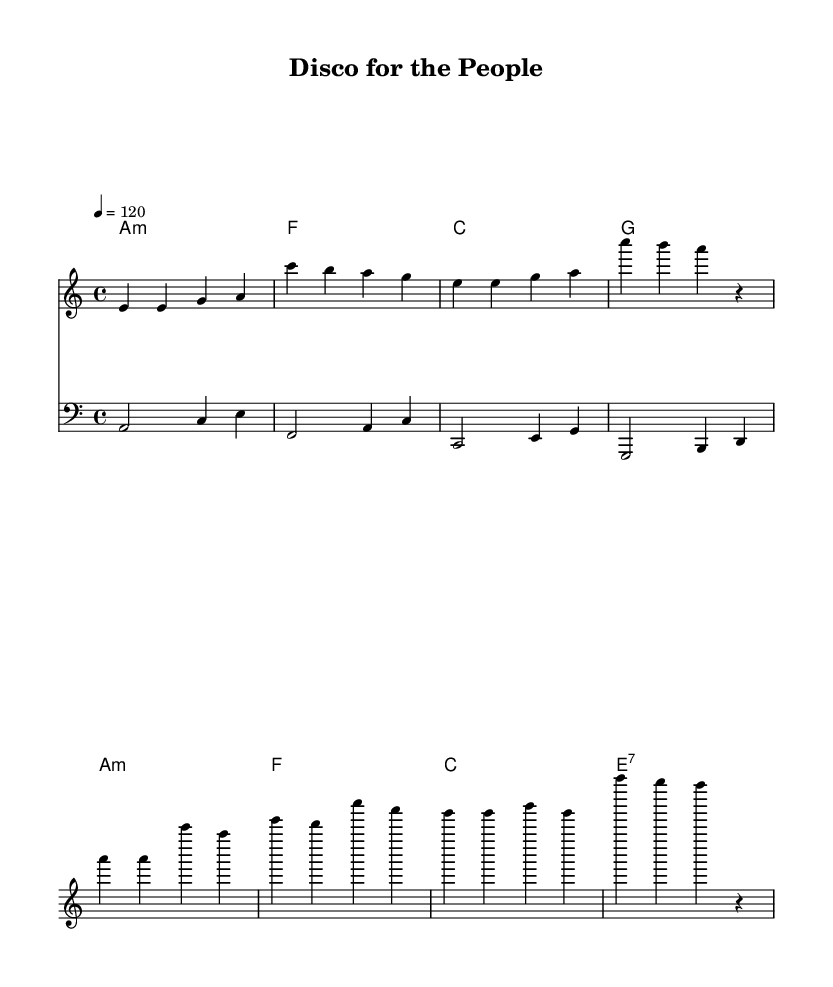What is the key signature of this music? The key signature is A minor, which is indicated by the absence of sharps or flats in the key signature line. A minor is the relative minor of C major.
Answer: A minor What is the time signature of this piece? The time signature is indicated by the "4/4" at the beginning of the score, signaling that there are four beats per measure and a quarter note gets one beat.
Answer: 4/4 What is the tempo marking for this composition? The tempo marking is shown as "4 = 120," which means that there are 120 beats per minute, and each beat is represented by a quarter note.
Answer: 120 How many measures are there in the melody section? The melody consists of 8 measures in total, as counted by the music notation in the sheet music. Each grouping of notes between the vertical lines represents one measure.
Answer: 8 What type of chord is the first chord in the harmonies? The first chord is an A minor chord, indicated by the "m" next to the letter A, which denotes that it is a minor chord.
Answer: A minor What is the primary theme addressed in the chorus lyrics? The primary theme in the chorus lyrics is economic equality and workers' rights, clearly illustrated by the lyrics that mention equality as a right and the call to join the fight.
Answer: Equality How does this piece reflect the disco genre? This piece reflects the disco genre through its upbeat tempo, repetitive structure, and emphasis on a danceable rhythm, typical of dance anthems associated with social movements.
Answer: Upbeat tempo 